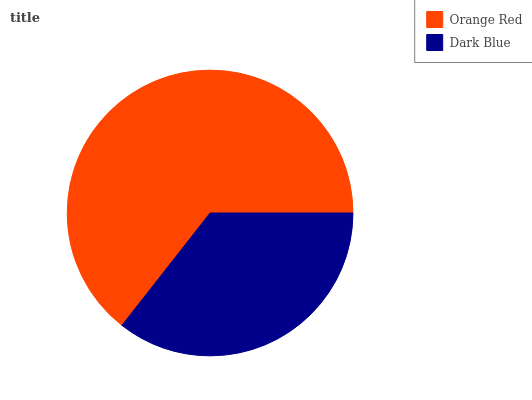Is Dark Blue the minimum?
Answer yes or no. Yes. Is Orange Red the maximum?
Answer yes or no. Yes. Is Dark Blue the maximum?
Answer yes or no. No. Is Orange Red greater than Dark Blue?
Answer yes or no. Yes. Is Dark Blue less than Orange Red?
Answer yes or no. Yes. Is Dark Blue greater than Orange Red?
Answer yes or no. No. Is Orange Red less than Dark Blue?
Answer yes or no. No. Is Orange Red the high median?
Answer yes or no. Yes. Is Dark Blue the low median?
Answer yes or no. Yes. Is Dark Blue the high median?
Answer yes or no. No. Is Orange Red the low median?
Answer yes or no. No. 